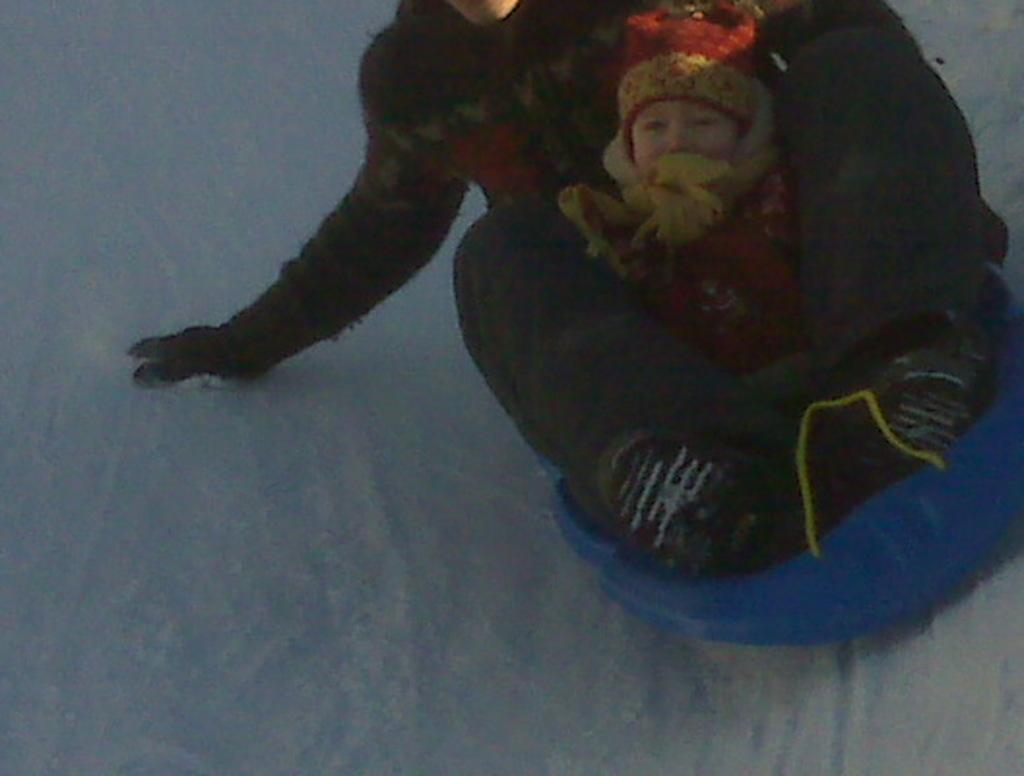Who is present in the image? There is a person in the image. Who else is with the person in the image? The person is with a baby. What activity are they engaged in? They are sliding on snow. What type of clothing are they wearing? Both the person and the baby are wearing woolen clothes. What instrument is the person playing while sliding on snow? There is no instrument present in the image; the person and the baby are simply sliding on snow. 